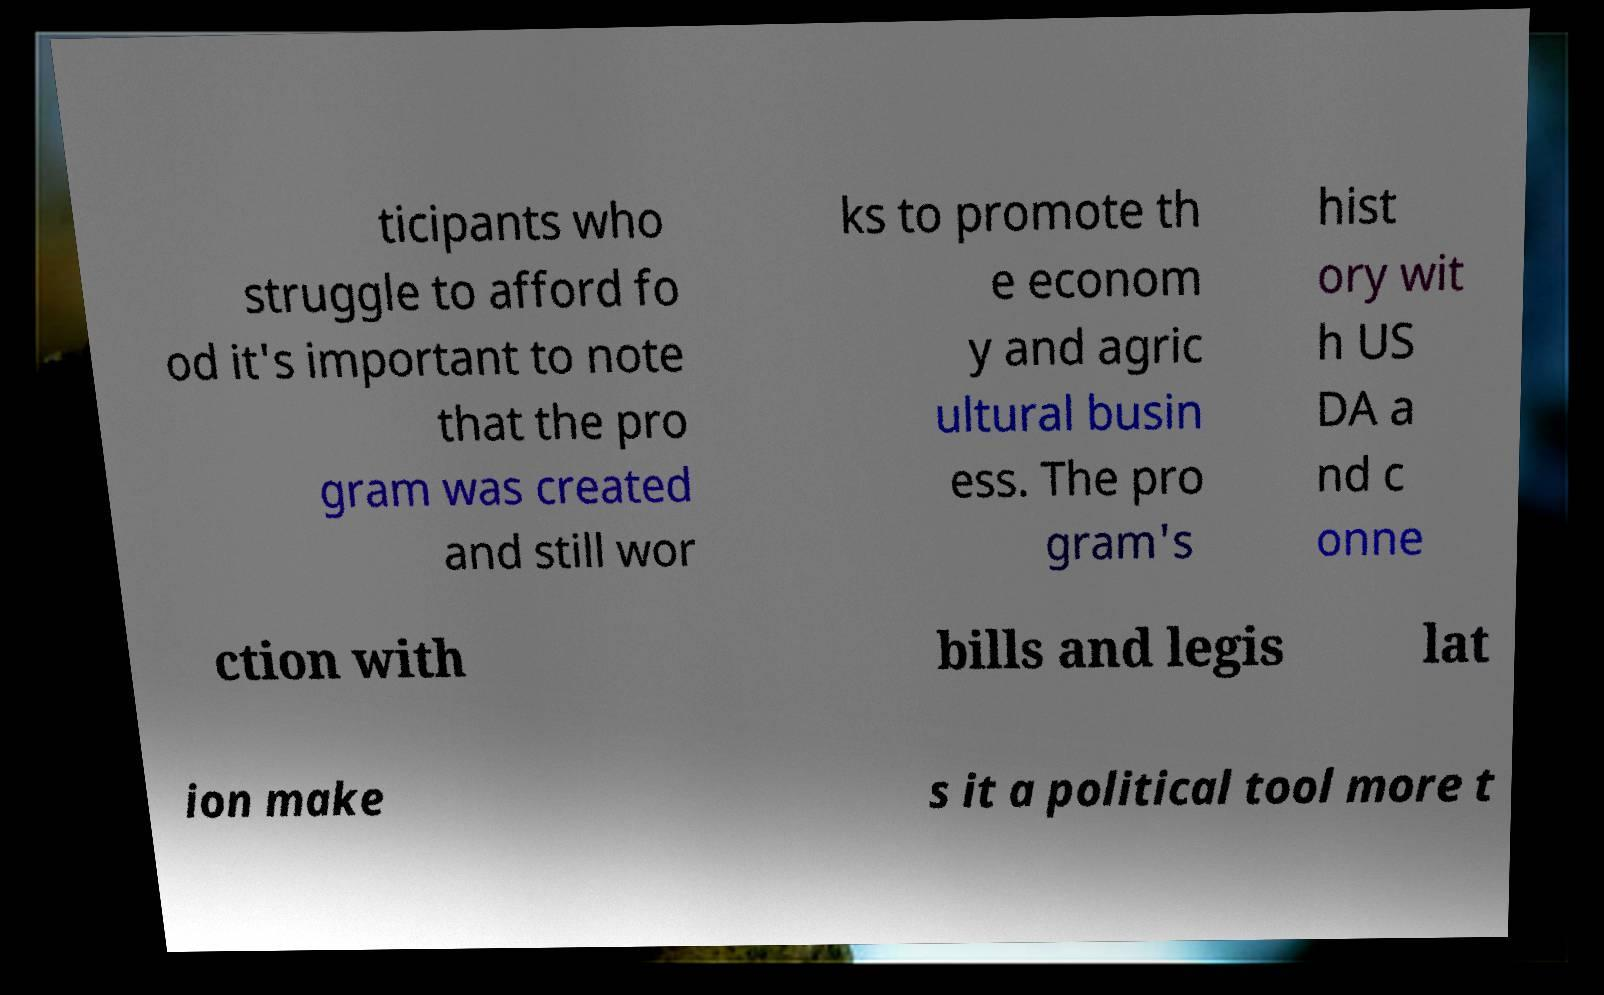For documentation purposes, I need the text within this image transcribed. Could you provide that? ticipants who struggle to afford fo od it's important to note that the pro gram was created and still wor ks to promote th e econom y and agric ultural busin ess. The pro gram's hist ory wit h US DA a nd c onne ction with bills and legis lat ion make s it a political tool more t 